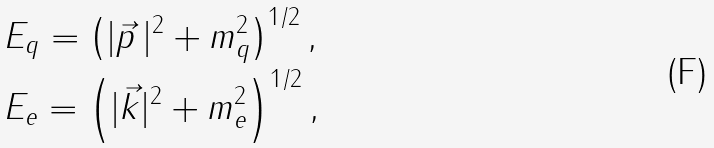Convert formula to latex. <formula><loc_0><loc_0><loc_500><loc_500>& E _ { q } = \left ( | \vec { p } \, | ^ { 2 } + m _ { q } ^ { 2 } \right ) ^ { 1 / 2 } , \\ & E _ { e } = \left ( | \vec { k } | ^ { 2 } + m _ { e } ^ { 2 } \right ) ^ { 1 / 2 } ,</formula> 